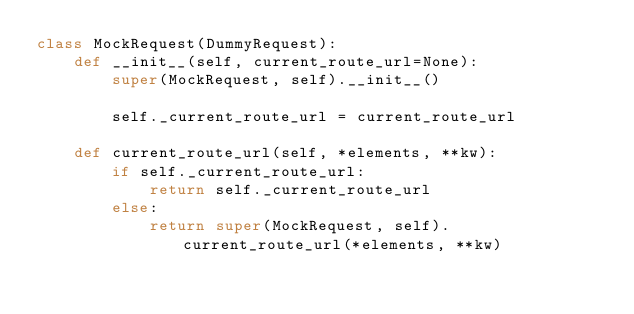Convert code to text. <code><loc_0><loc_0><loc_500><loc_500><_Python_>class MockRequest(DummyRequest):
    def __init__(self, current_route_url=None):
        super(MockRequest, self).__init__()

        self._current_route_url = current_route_url

    def current_route_url(self, *elements, **kw):
        if self._current_route_url:
            return self._current_route_url
        else:
            return super(MockRequest, self).current_route_url(*elements, **kw)
</code> 